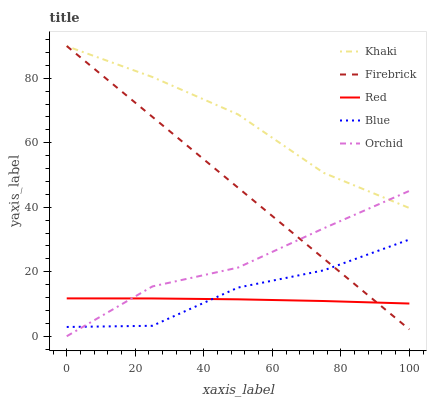Does Red have the minimum area under the curve?
Answer yes or no. Yes. Does Khaki have the maximum area under the curve?
Answer yes or no. Yes. Does Firebrick have the minimum area under the curve?
Answer yes or no. No. Does Firebrick have the maximum area under the curve?
Answer yes or no. No. Is Firebrick the smoothest?
Answer yes or no. Yes. Is Blue the roughest?
Answer yes or no. Yes. Is Khaki the smoothest?
Answer yes or no. No. Is Khaki the roughest?
Answer yes or no. No. Does Orchid have the lowest value?
Answer yes or no. Yes. Does Firebrick have the lowest value?
Answer yes or no. No. Does Firebrick have the highest value?
Answer yes or no. Yes. Does Khaki have the highest value?
Answer yes or no. No. Is Red less than Khaki?
Answer yes or no. Yes. Is Khaki greater than Blue?
Answer yes or no. Yes. Does Blue intersect Orchid?
Answer yes or no. Yes. Is Blue less than Orchid?
Answer yes or no. No. Is Blue greater than Orchid?
Answer yes or no. No. Does Red intersect Khaki?
Answer yes or no. No. 